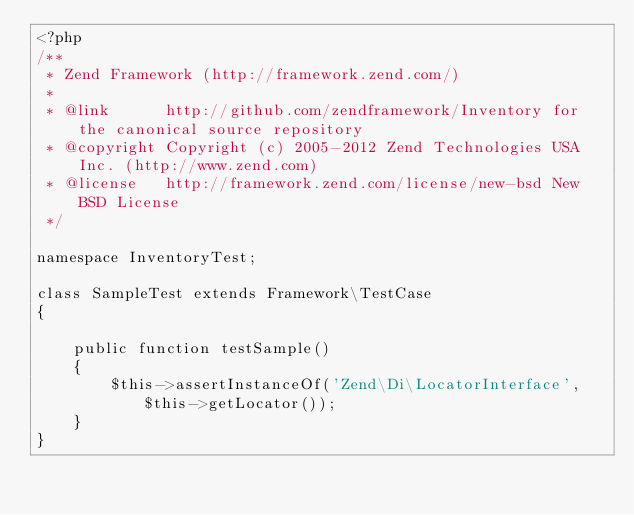<code> <loc_0><loc_0><loc_500><loc_500><_PHP_><?php
/**
 * Zend Framework (http://framework.zend.com/)
 *
 * @link      http://github.com/zendframework/Inventory for the canonical source repository
 * @copyright Copyright (c) 2005-2012 Zend Technologies USA Inc. (http://www.zend.com)
 * @license   http://framework.zend.com/license/new-bsd New BSD License
 */

namespace InventoryTest;

class SampleTest extends Framework\TestCase
{

    public function testSample()
    {
        $this->assertInstanceOf('Zend\Di\LocatorInterface', $this->getLocator());
    }
}
</code> 